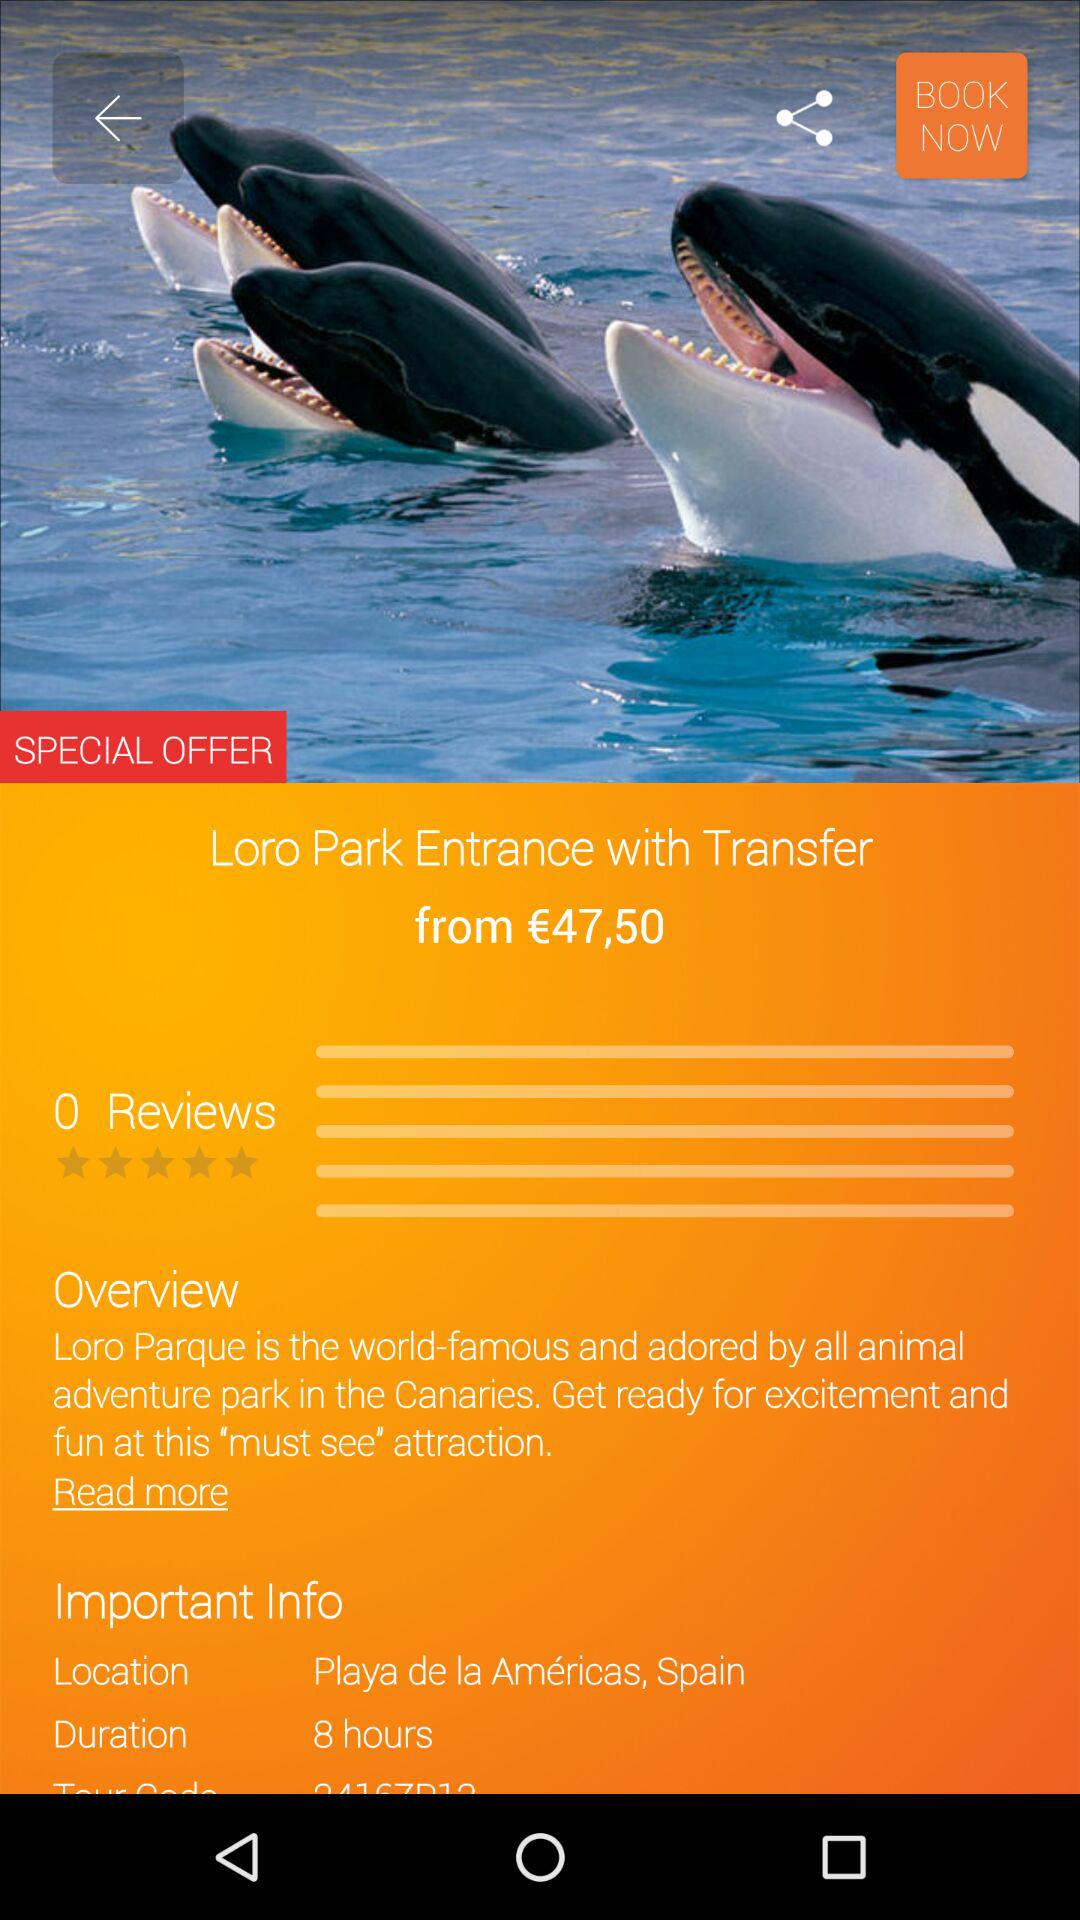What is the location shown on the screen? The location shown on the screen is Playa de la Américas, Spain. 